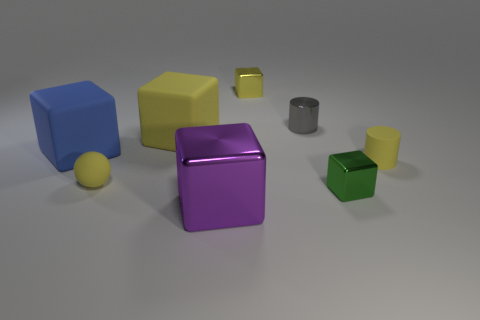Which objects have rounded shapes instead of angular edges? The objects with rounded shapes are the small yellow and green spheres, in contrast to the various cubes and the cylinder that have angular edges. 